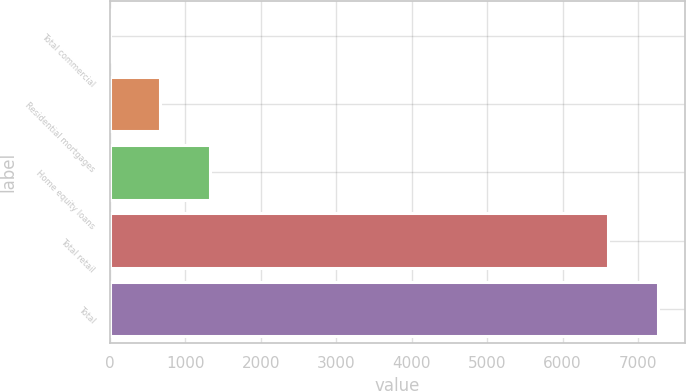Convert chart to OTSL. <chart><loc_0><loc_0><loc_500><loc_500><bar_chart><fcel>Total commercial<fcel>Residential mortgages<fcel>Home equity loans<fcel>Total retail<fcel>Total<nl><fcel>7<fcel>666.9<fcel>1326.8<fcel>6599<fcel>7258.9<nl></chart> 